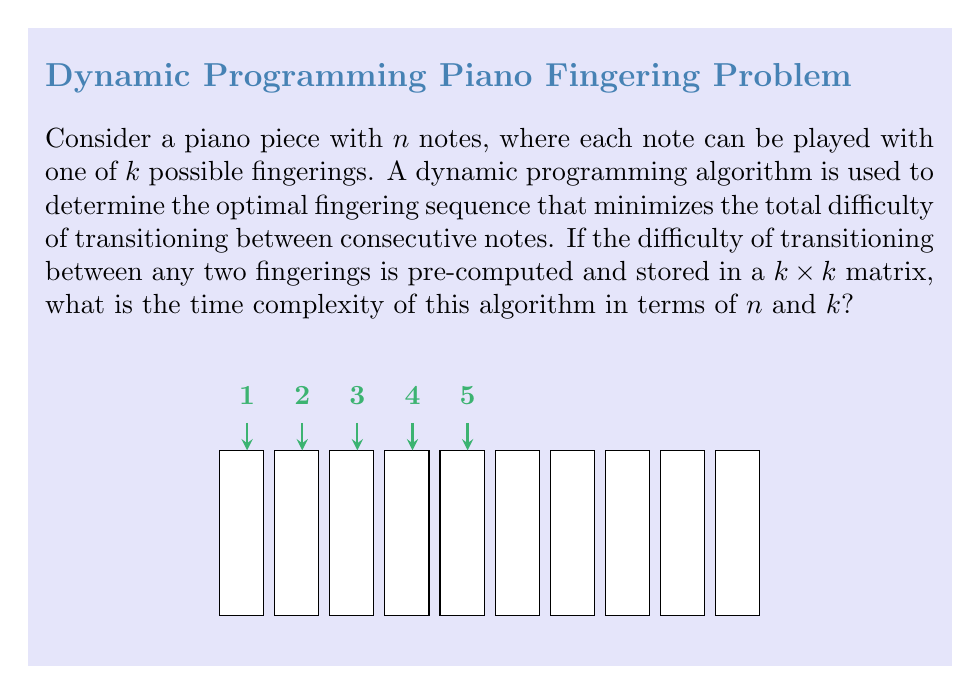Show me your answer to this math problem. Let's break down the dynamic programming algorithm and analyze its time complexity:

1) First, we need to understand the structure of the dynamic programming table:
   - We'll have a table of size $n \times k$, where $n$ is the number of notes and $k$ is the number of possible fingerings.
   - Each cell $(i,j)$ in this table represents the minimum difficulty of playing the first $i$ notes, ending with fingering $j$ for the $i$-th note.

2) To fill each cell in the table, we need to consider all possible fingerings for the previous note and choose the one that minimizes the total difficulty:
   - For each cell $(i,j)$, we look at all $k$ cells in the previous row $(i-1, 1)$ to $(i-1, k)$.
   - We add the transition difficulty from the previous fingering to the current fingering $j$.
   - We choose the minimum of these $k$ options.

3) The time complexity for filling each cell is $O(k)$, as we need to consider $k$ previous fingerings.

4) We need to fill $n \times k$ cells in total.

5) Therefore, the overall time complexity is:
   $$ O(n \times k \times k) = O(nk^2) $$

6) The additional $k$ in the complexity comes from the need to consider all $k$ possible previous fingerings for each cell.

7) Note that we assumed the transition difficulties are pre-computed and stored in a $k \times k$ matrix, which takes $O(k^2)$ space but doesn't affect the time complexity of the main algorithm.

This time complexity is polynomial in both $n$ and $k$, making it efficient for reasonably sized inputs, especially considering that $k$ (the number of fingering options) is typically small and constant for a given instrument.
Answer: $O(nk^2)$ 